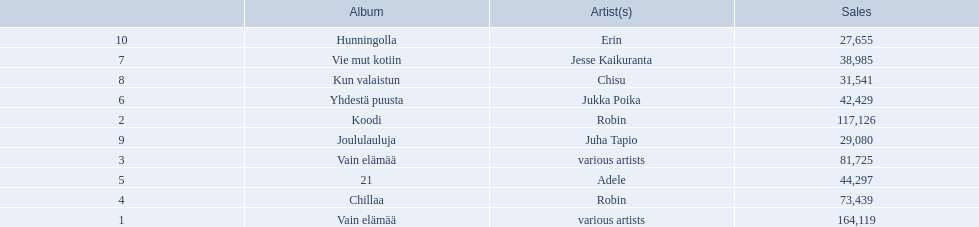Which albums had number-one albums in finland in 2012? 1, Vain elämää, Koodi, Vain elämää, Chillaa, 21, Yhdestä puusta, Vie mut kotiin, Kun valaistun, Joululauluja, Hunningolla. Of those albums, which were recorded by only one artist? Koodi, Chillaa, 21, Yhdestä puusta, Vie mut kotiin, Kun valaistun, Joululauluja, Hunningolla. Which albums made between 30,000 and 45,000 in sales? 21, Yhdestä puusta, Vie mut kotiin, Kun valaistun. Of those albums which had the highest sales? 21. Who was the artist for that album? Adele. 